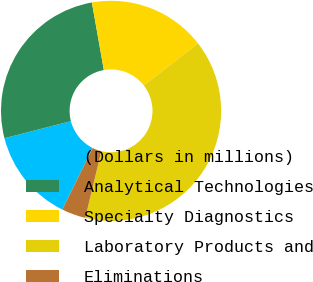Convert chart to OTSL. <chart><loc_0><loc_0><loc_500><loc_500><pie_chart><fcel>(Dollars in millions)<fcel>Analytical Technologies<fcel>Specialty Diagnostics<fcel>Laboratory Products and<fcel>Eliminations<nl><fcel>13.7%<fcel>26.21%<fcel>17.28%<fcel>39.27%<fcel>3.54%<nl></chart> 